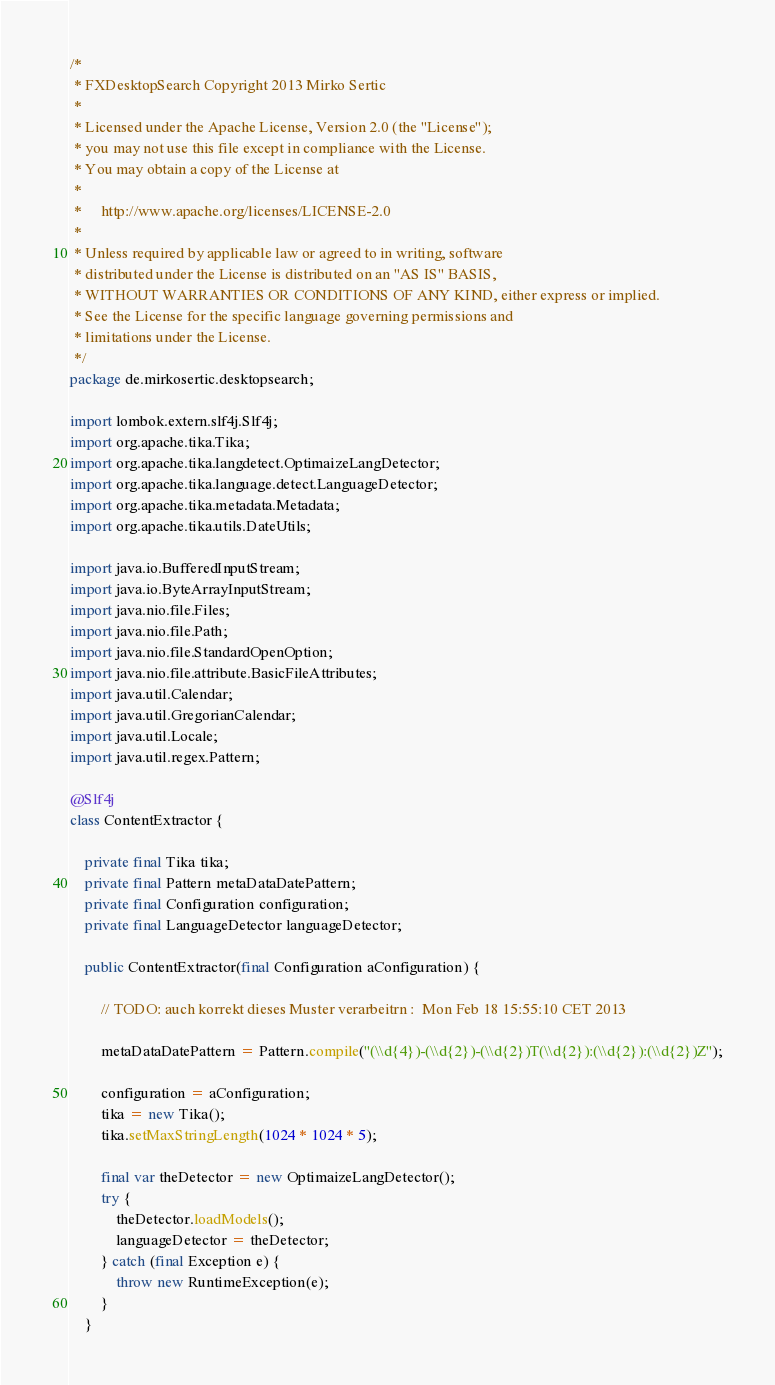Convert code to text. <code><loc_0><loc_0><loc_500><loc_500><_Java_>/*
 * FXDesktopSearch Copyright 2013 Mirko Sertic
 *
 * Licensed under the Apache License, Version 2.0 (the "License");
 * you may not use this file except in compliance with the License.
 * You may obtain a copy of the License at
 *
 *     http://www.apache.org/licenses/LICENSE-2.0
 *
 * Unless required by applicable law or agreed to in writing, software
 * distributed under the License is distributed on an "AS IS" BASIS,
 * WITHOUT WARRANTIES OR CONDITIONS OF ANY KIND, either express or implied.
 * See the License for the specific language governing permissions and
 * limitations under the License.
 */
package de.mirkosertic.desktopsearch;

import lombok.extern.slf4j.Slf4j;
import org.apache.tika.Tika;
import org.apache.tika.langdetect.OptimaizeLangDetector;
import org.apache.tika.language.detect.LanguageDetector;
import org.apache.tika.metadata.Metadata;
import org.apache.tika.utils.DateUtils;

import java.io.BufferedInputStream;
import java.io.ByteArrayInputStream;
import java.nio.file.Files;
import java.nio.file.Path;
import java.nio.file.StandardOpenOption;
import java.nio.file.attribute.BasicFileAttributes;
import java.util.Calendar;
import java.util.GregorianCalendar;
import java.util.Locale;
import java.util.regex.Pattern;

@Slf4j
class ContentExtractor {

    private final Tika tika;
    private final Pattern metaDataDatePattern;
    private final Configuration configuration;
    private final LanguageDetector languageDetector;

    public ContentExtractor(final Configuration aConfiguration) {

        // TODO: auch korrekt dieses Muster verarbeitrn :  Mon Feb 18 15:55:10 CET 2013

        metaDataDatePattern = Pattern.compile("(\\d{4})-(\\d{2})-(\\d{2})T(\\d{2}):(\\d{2}):(\\d{2})Z");

        configuration = aConfiguration;
        tika = new Tika();
        tika.setMaxStringLength(1024 * 1024 * 5);

        final var theDetector = new OptimaizeLangDetector();
        try {
            theDetector.loadModels();
            languageDetector = theDetector;
        } catch (final Exception e) {
            throw new RuntimeException(e);
        }
    }
</code> 